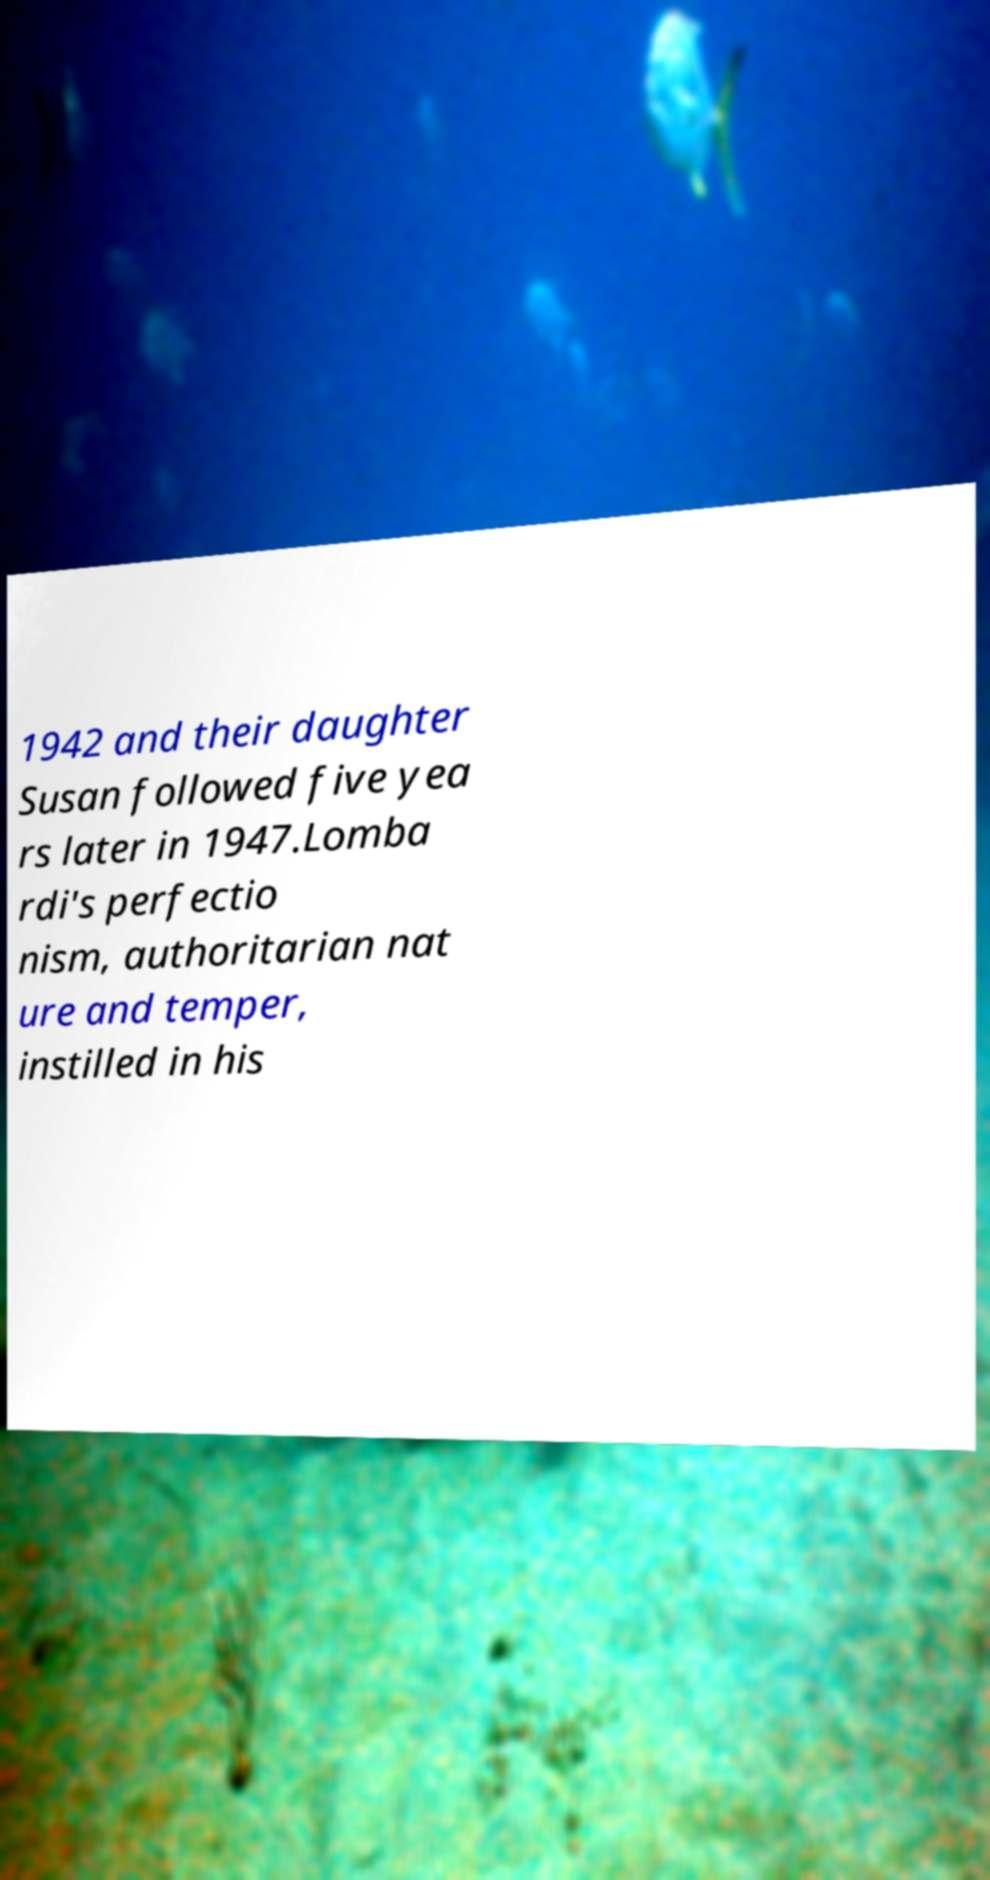There's text embedded in this image that I need extracted. Can you transcribe it verbatim? 1942 and their daughter Susan followed five yea rs later in 1947.Lomba rdi's perfectio nism, authoritarian nat ure and temper, instilled in his 